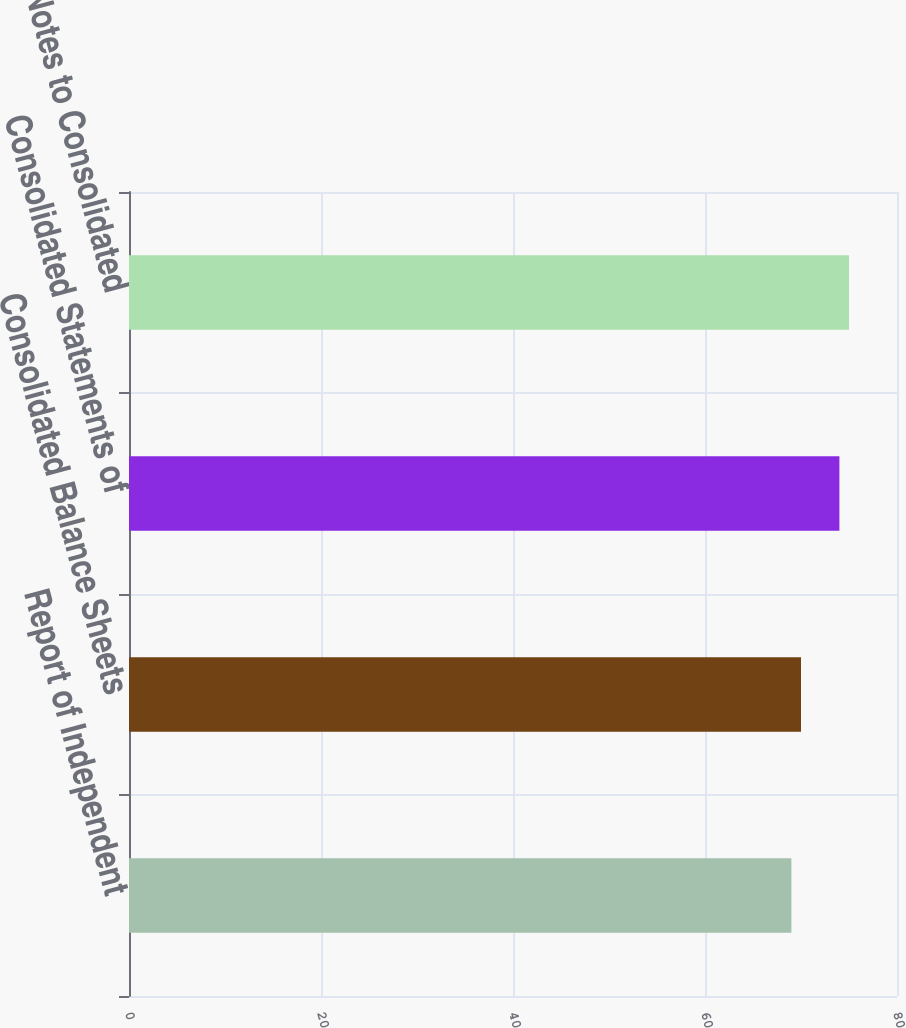Convert chart to OTSL. <chart><loc_0><loc_0><loc_500><loc_500><bar_chart><fcel>Report of Independent<fcel>Consolidated Balance Sheets<fcel>Consolidated Statements of<fcel>Notes to Consolidated<nl><fcel>69<fcel>70<fcel>74<fcel>75<nl></chart> 